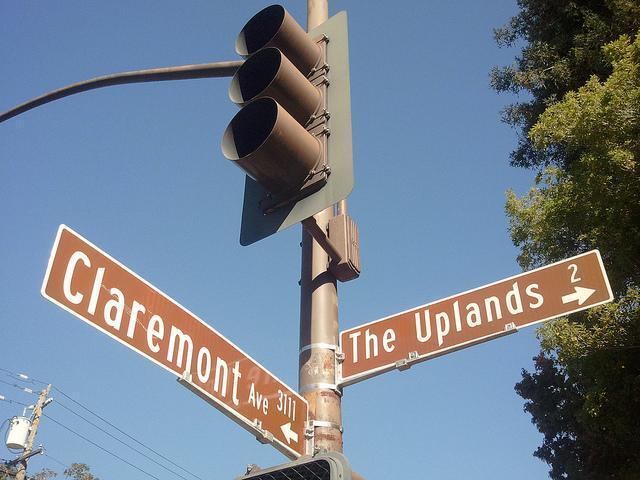How many women are carrying red flower bouquets?
Give a very brief answer. 0. 